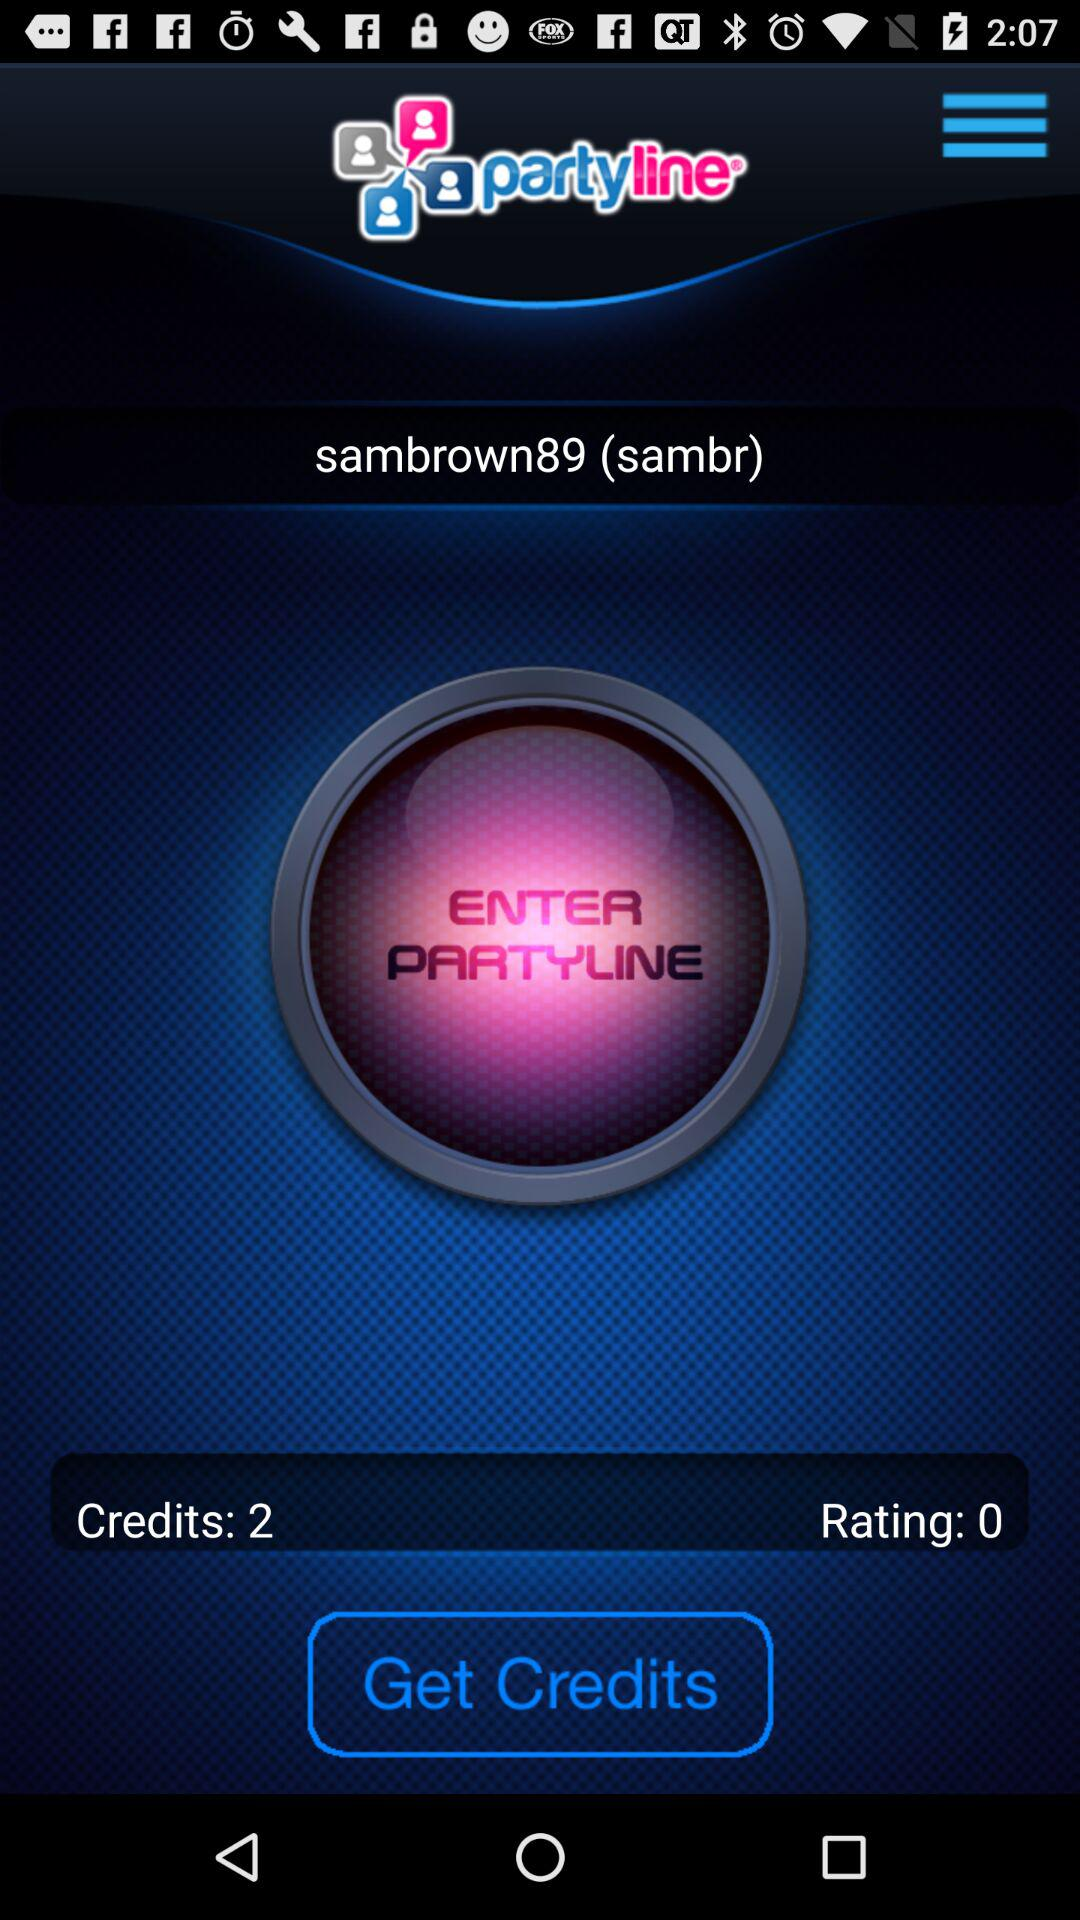What is the user name? The user name is sambrown89 (sambr). 